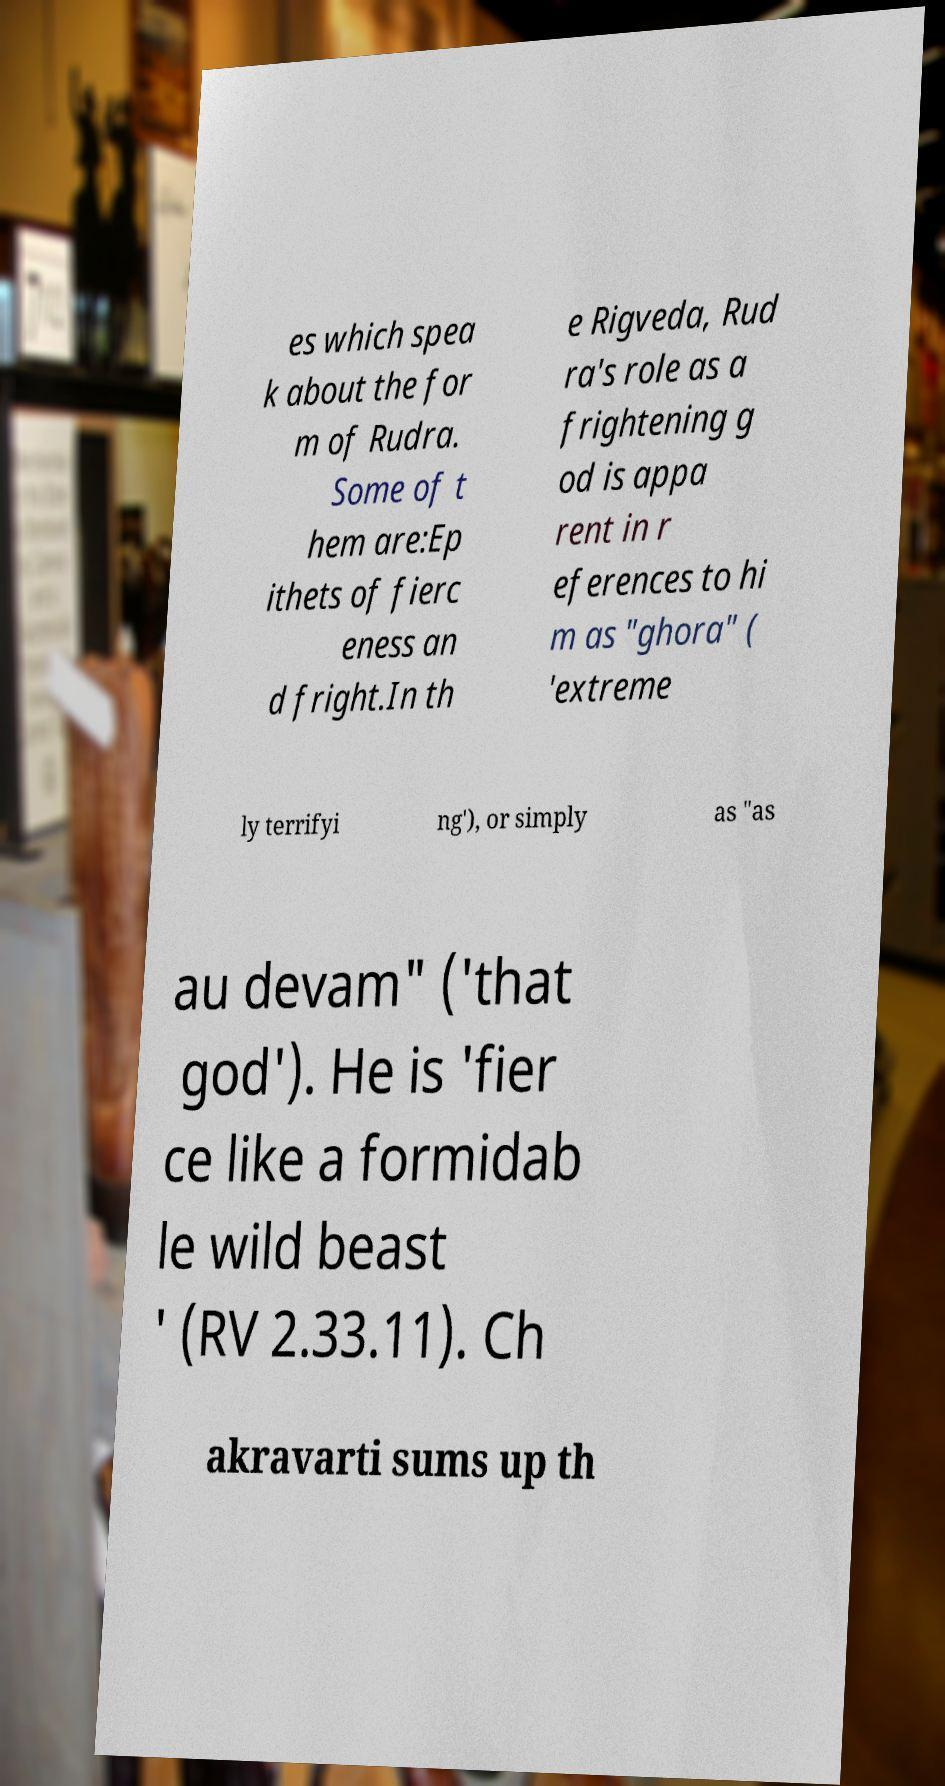Please read and relay the text visible in this image. What does it say? es which spea k about the for m of Rudra. Some of t hem are:Ep ithets of fierc eness an d fright.In th e Rigveda, Rud ra's role as a frightening g od is appa rent in r eferences to hi m as "ghora" ( 'extreme ly terrifyi ng'), or simply as "as au devam" ('that god'). He is 'fier ce like a formidab le wild beast ' (RV 2.33.11). Ch akravarti sums up th 